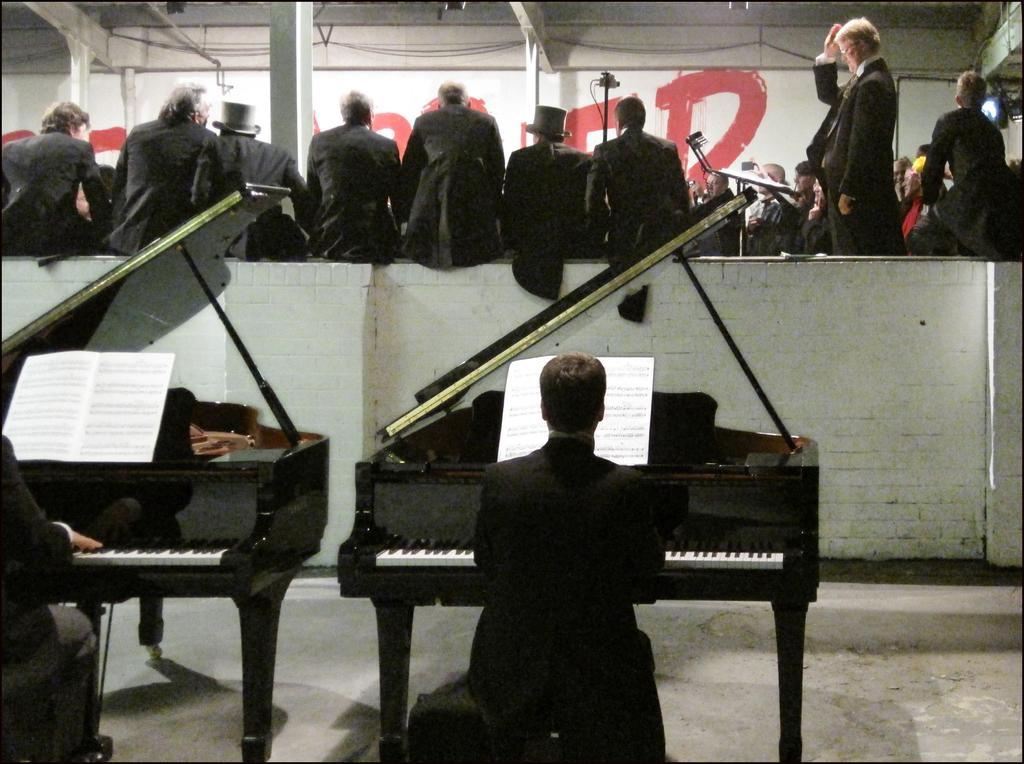How many people are in the image? There are two people in the image. What are the two people doing in the image? The two people are playing the piano. What can be seen in the background of the image? There is a wall in the background of the image. Are there any other people visible in the image? Yes, there are people sitting on the wall in the background. What type of chalk is being used by the people playing the piano in the image? There is no chalk present in the image; the two people are playing the piano without any chalk. 